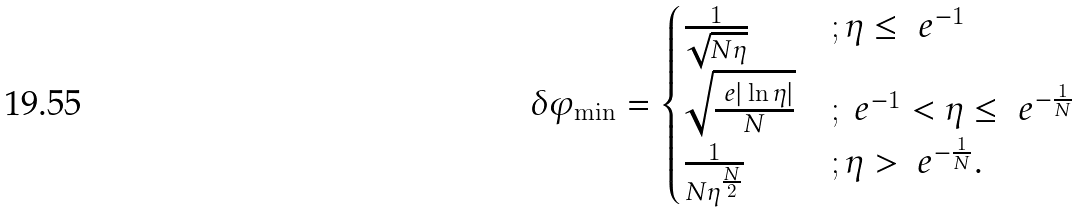<formula> <loc_0><loc_0><loc_500><loc_500>\delta \varphi _ { \min } = \begin{cases} \frac { 1 } { \sqrt { N \eta } } & ; \eta \leq \ e ^ { - 1 } \\ \sqrt { \frac { \ e | \ln { \eta } | } { N } } & ; \ e ^ { - 1 } < \eta \leq \ e ^ { - \frac { 1 } { N } } \\ \frac { 1 } { N \eta ^ { \frac { N } { 2 } } } & ; \eta > \ e ^ { - \frac { 1 } { N } } . \end{cases}</formula> 